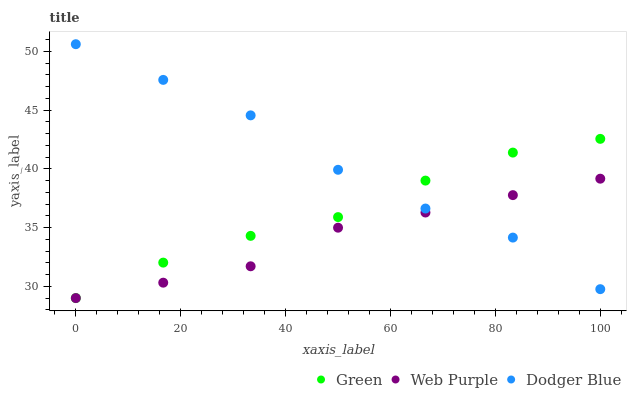Does Web Purple have the minimum area under the curve?
Answer yes or no. Yes. Does Dodger Blue have the maximum area under the curve?
Answer yes or no. Yes. Does Green have the minimum area under the curve?
Answer yes or no. No. Does Green have the maximum area under the curve?
Answer yes or no. No. Is Web Purple the smoothest?
Answer yes or no. Yes. Is Dodger Blue the roughest?
Answer yes or no. Yes. Is Green the smoothest?
Answer yes or no. No. Is Green the roughest?
Answer yes or no. No. Does Web Purple have the lowest value?
Answer yes or no. Yes. Does Dodger Blue have the highest value?
Answer yes or no. Yes. Does Green have the highest value?
Answer yes or no. No. Does Green intersect Web Purple?
Answer yes or no. Yes. Is Green less than Web Purple?
Answer yes or no. No. Is Green greater than Web Purple?
Answer yes or no. No. 